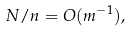<formula> <loc_0><loc_0><loc_500><loc_500>N / n = O ( m ^ { - 1 } ) ,</formula> 